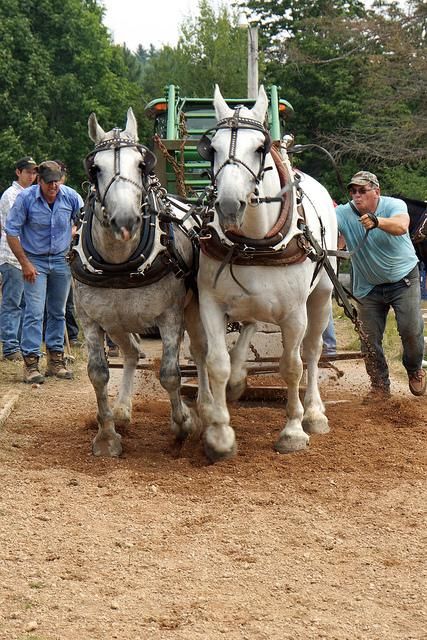What is the man on the right doing?

Choices:
A) stealing horses
B) beating horses
C) feeding horses
D) controlling horses controlling horses 